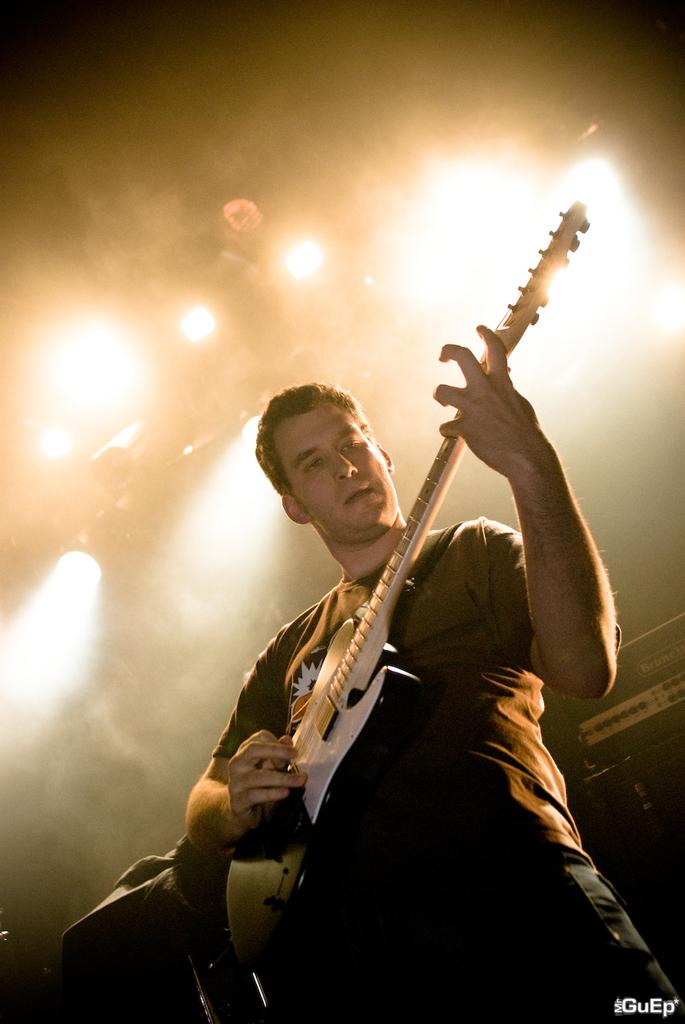What is the main subject of the image? There is a person in the image. What is the person doing in the image? The person is playing a guitar. What type of bell can be heard ringing in the image? There is no bell present in the image, and therefore no sound can be heard. 